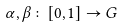Convert formula to latex. <formula><loc_0><loc_0><loc_500><loc_500>\alpha , \beta \colon [ 0 , 1 ] \to G</formula> 